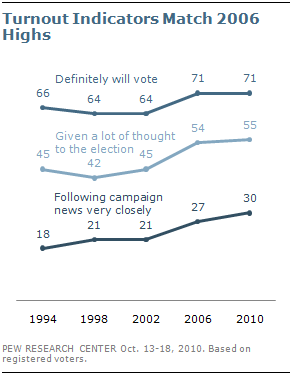Give some essential details in this illustration. The difference in the leftmost and rightmost values of the upper line in the graph is 5. The middle line indicator has been given much thought in the election process. 